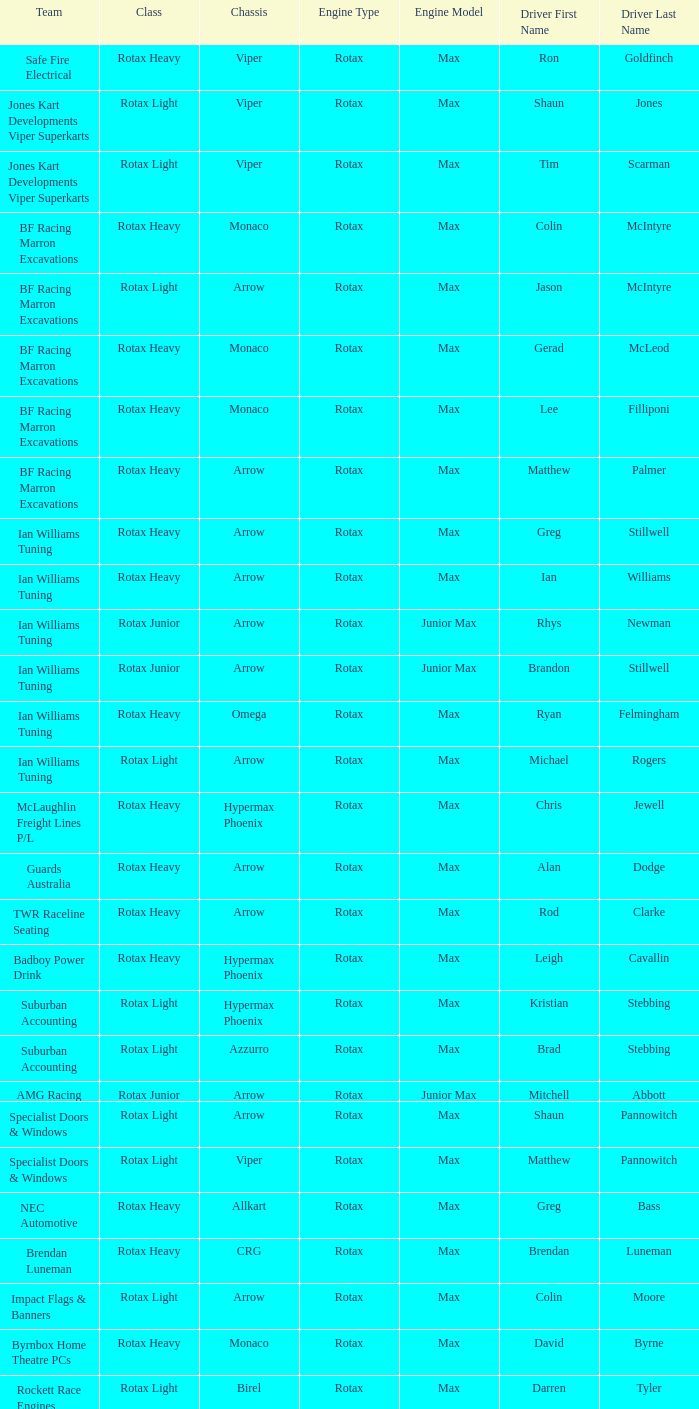What is the name of the team whose class is Rotax Light? Jones Kart Developments Viper Superkarts, Jones Kart Developments Viper Superkarts, BF Racing Marron Excavations, Ian Williams Tuning, Suburban Accounting, Suburban Accounting, Specialist Doors & Windows, Specialist Doors & Windows, Impact Flags & Banners, Rockett Race Engines, Racecentre, Doug Savage. 